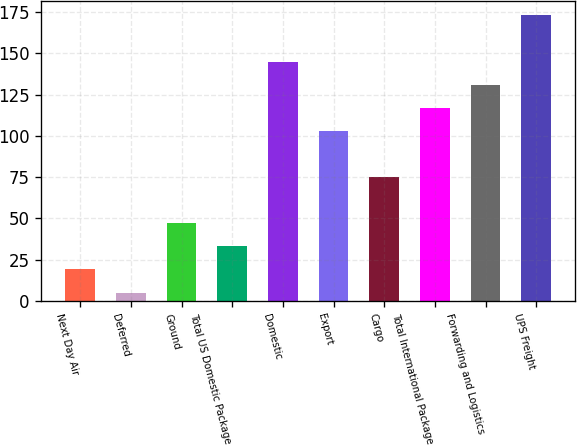<chart> <loc_0><loc_0><loc_500><loc_500><bar_chart><fcel>Next Day Air<fcel>Deferred<fcel>Ground<fcel>Total US Domestic Package<fcel>Domestic<fcel>Export<fcel>Cargo<fcel>Total International Package<fcel>Forwarding and Logistics<fcel>UPS Freight<nl><fcel>19.08<fcel>5.1<fcel>47.04<fcel>33.06<fcel>144.9<fcel>102.96<fcel>75<fcel>116.94<fcel>130.92<fcel>172.86<nl></chart> 